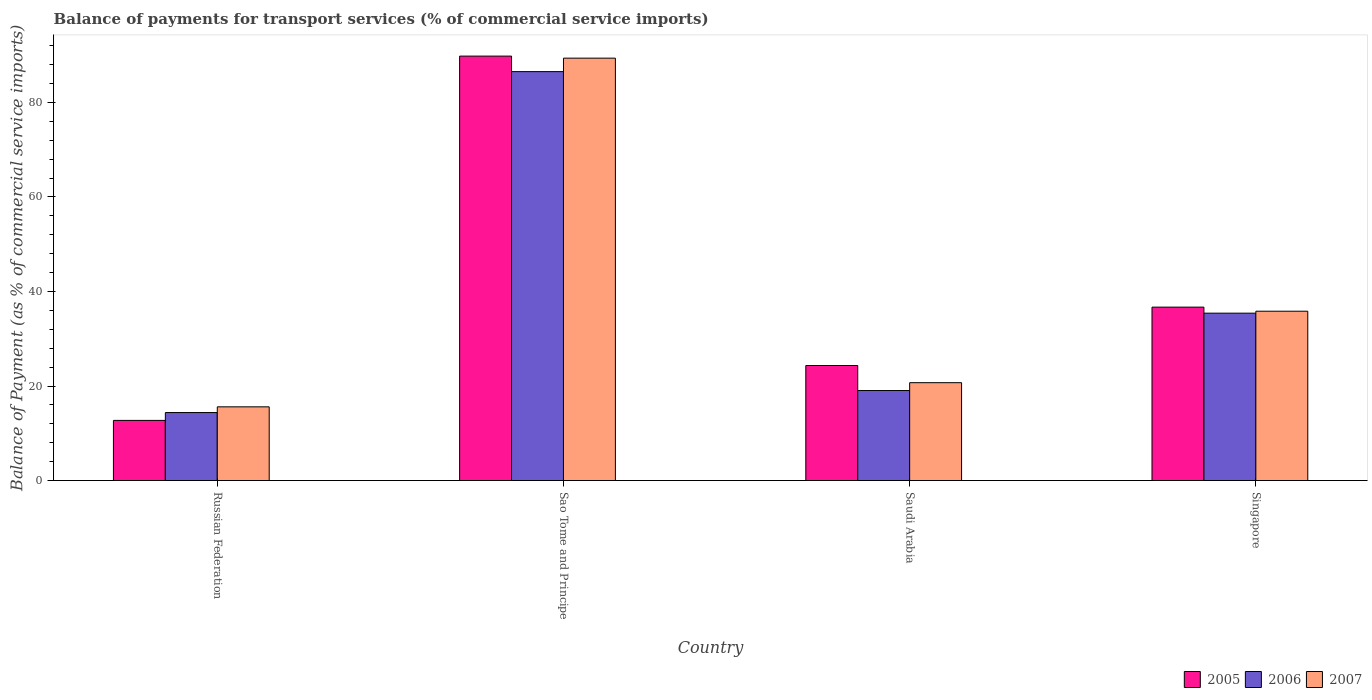How many different coloured bars are there?
Your answer should be compact. 3. How many bars are there on the 3rd tick from the left?
Provide a succinct answer. 3. How many bars are there on the 1st tick from the right?
Provide a short and direct response. 3. What is the label of the 3rd group of bars from the left?
Give a very brief answer. Saudi Arabia. In how many cases, is the number of bars for a given country not equal to the number of legend labels?
Give a very brief answer. 0. What is the balance of payments for transport services in 2007 in Singapore?
Make the answer very short. 35.83. Across all countries, what is the maximum balance of payments for transport services in 2006?
Your response must be concise. 86.52. Across all countries, what is the minimum balance of payments for transport services in 2006?
Keep it short and to the point. 14.39. In which country was the balance of payments for transport services in 2007 maximum?
Offer a very short reply. Sao Tome and Principe. In which country was the balance of payments for transport services in 2007 minimum?
Offer a very short reply. Russian Federation. What is the total balance of payments for transport services in 2005 in the graph?
Provide a succinct answer. 163.58. What is the difference between the balance of payments for transport services in 2006 in Russian Federation and that in Singapore?
Provide a short and direct response. -21.03. What is the difference between the balance of payments for transport services in 2005 in Sao Tome and Principe and the balance of payments for transport services in 2006 in Singapore?
Your answer should be very brief. 54.39. What is the average balance of payments for transport services in 2005 per country?
Your answer should be compact. 40.89. What is the difference between the balance of payments for transport services of/in 2007 and balance of payments for transport services of/in 2006 in Sao Tome and Principe?
Make the answer very short. 2.85. In how many countries, is the balance of payments for transport services in 2005 greater than 52 %?
Offer a very short reply. 1. What is the ratio of the balance of payments for transport services in 2006 in Russian Federation to that in Singapore?
Keep it short and to the point. 0.41. What is the difference between the highest and the second highest balance of payments for transport services in 2005?
Offer a very short reply. -65.46. What is the difference between the highest and the lowest balance of payments for transport services in 2006?
Offer a very short reply. 72.13. In how many countries, is the balance of payments for transport services in 2005 greater than the average balance of payments for transport services in 2005 taken over all countries?
Offer a terse response. 1. Is the sum of the balance of payments for transport services in 2005 in Sao Tome and Principe and Saudi Arabia greater than the maximum balance of payments for transport services in 2006 across all countries?
Provide a short and direct response. Yes. What does the 3rd bar from the left in Sao Tome and Principe represents?
Your response must be concise. 2007. What does the 2nd bar from the right in Singapore represents?
Your answer should be compact. 2006. Is it the case that in every country, the sum of the balance of payments for transport services in 2006 and balance of payments for transport services in 2005 is greater than the balance of payments for transport services in 2007?
Give a very brief answer. Yes. How many bars are there?
Provide a short and direct response. 12. How many countries are there in the graph?
Your answer should be very brief. 4. What is the difference between two consecutive major ticks on the Y-axis?
Ensure brevity in your answer.  20. Are the values on the major ticks of Y-axis written in scientific E-notation?
Offer a terse response. No. Does the graph contain any zero values?
Provide a short and direct response. No. Where does the legend appear in the graph?
Your response must be concise. Bottom right. How many legend labels are there?
Ensure brevity in your answer.  3. How are the legend labels stacked?
Your answer should be very brief. Horizontal. What is the title of the graph?
Offer a very short reply. Balance of payments for transport services (% of commercial service imports). What is the label or title of the Y-axis?
Keep it short and to the point. Balance of Payment (as % of commercial service imports). What is the Balance of Payment (as % of commercial service imports) in 2005 in Russian Federation?
Your answer should be compact. 12.73. What is the Balance of Payment (as % of commercial service imports) of 2006 in Russian Federation?
Your answer should be very brief. 14.39. What is the Balance of Payment (as % of commercial service imports) of 2007 in Russian Federation?
Keep it short and to the point. 15.6. What is the Balance of Payment (as % of commercial service imports) of 2005 in Sao Tome and Principe?
Provide a succinct answer. 89.8. What is the Balance of Payment (as % of commercial service imports) of 2006 in Sao Tome and Principe?
Offer a terse response. 86.52. What is the Balance of Payment (as % of commercial service imports) of 2007 in Sao Tome and Principe?
Your answer should be compact. 89.37. What is the Balance of Payment (as % of commercial service imports) of 2005 in Saudi Arabia?
Offer a terse response. 24.34. What is the Balance of Payment (as % of commercial service imports) in 2006 in Saudi Arabia?
Provide a succinct answer. 19.05. What is the Balance of Payment (as % of commercial service imports) of 2007 in Saudi Arabia?
Your answer should be compact. 20.71. What is the Balance of Payment (as % of commercial service imports) of 2005 in Singapore?
Make the answer very short. 36.69. What is the Balance of Payment (as % of commercial service imports) in 2006 in Singapore?
Give a very brief answer. 35.42. What is the Balance of Payment (as % of commercial service imports) of 2007 in Singapore?
Your answer should be compact. 35.83. Across all countries, what is the maximum Balance of Payment (as % of commercial service imports) of 2005?
Give a very brief answer. 89.8. Across all countries, what is the maximum Balance of Payment (as % of commercial service imports) of 2006?
Ensure brevity in your answer.  86.52. Across all countries, what is the maximum Balance of Payment (as % of commercial service imports) of 2007?
Provide a short and direct response. 89.37. Across all countries, what is the minimum Balance of Payment (as % of commercial service imports) in 2005?
Ensure brevity in your answer.  12.73. Across all countries, what is the minimum Balance of Payment (as % of commercial service imports) of 2006?
Your answer should be very brief. 14.39. Across all countries, what is the minimum Balance of Payment (as % of commercial service imports) of 2007?
Ensure brevity in your answer.  15.6. What is the total Balance of Payment (as % of commercial service imports) in 2005 in the graph?
Keep it short and to the point. 163.58. What is the total Balance of Payment (as % of commercial service imports) of 2006 in the graph?
Your response must be concise. 155.38. What is the total Balance of Payment (as % of commercial service imports) in 2007 in the graph?
Offer a terse response. 161.51. What is the difference between the Balance of Payment (as % of commercial service imports) in 2005 in Russian Federation and that in Sao Tome and Principe?
Your response must be concise. -77.07. What is the difference between the Balance of Payment (as % of commercial service imports) in 2006 in Russian Federation and that in Sao Tome and Principe?
Provide a succinct answer. -72.13. What is the difference between the Balance of Payment (as % of commercial service imports) in 2007 in Russian Federation and that in Sao Tome and Principe?
Offer a very short reply. -73.77. What is the difference between the Balance of Payment (as % of commercial service imports) in 2005 in Russian Federation and that in Saudi Arabia?
Give a very brief answer. -11.61. What is the difference between the Balance of Payment (as % of commercial service imports) of 2006 in Russian Federation and that in Saudi Arabia?
Offer a very short reply. -4.66. What is the difference between the Balance of Payment (as % of commercial service imports) in 2007 in Russian Federation and that in Saudi Arabia?
Give a very brief answer. -5.11. What is the difference between the Balance of Payment (as % of commercial service imports) in 2005 in Russian Federation and that in Singapore?
Provide a succinct answer. -23.96. What is the difference between the Balance of Payment (as % of commercial service imports) in 2006 in Russian Federation and that in Singapore?
Provide a short and direct response. -21.03. What is the difference between the Balance of Payment (as % of commercial service imports) in 2007 in Russian Federation and that in Singapore?
Your answer should be compact. -20.23. What is the difference between the Balance of Payment (as % of commercial service imports) of 2005 in Sao Tome and Principe and that in Saudi Arabia?
Ensure brevity in your answer.  65.46. What is the difference between the Balance of Payment (as % of commercial service imports) in 2006 in Sao Tome and Principe and that in Saudi Arabia?
Give a very brief answer. 67.47. What is the difference between the Balance of Payment (as % of commercial service imports) of 2007 in Sao Tome and Principe and that in Saudi Arabia?
Offer a very short reply. 68.66. What is the difference between the Balance of Payment (as % of commercial service imports) of 2005 in Sao Tome and Principe and that in Singapore?
Make the answer very short. 53.11. What is the difference between the Balance of Payment (as % of commercial service imports) of 2006 in Sao Tome and Principe and that in Singapore?
Give a very brief answer. 51.1. What is the difference between the Balance of Payment (as % of commercial service imports) of 2007 in Sao Tome and Principe and that in Singapore?
Your response must be concise. 53.54. What is the difference between the Balance of Payment (as % of commercial service imports) of 2005 in Saudi Arabia and that in Singapore?
Your response must be concise. -12.35. What is the difference between the Balance of Payment (as % of commercial service imports) in 2006 in Saudi Arabia and that in Singapore?
Provide a succinct answer. -16.37. What is the difference between the Balance of Payment (as % of commercial service imports) of 2007 in Saudi Arabia and that in Singapore?
Your answer should be very brief. -15.12. What is the difference between the Balance of Payment (as % of commercial service imports) of 2005 in Russian Federation and the Balance of Payment (as % of commercial service imports) of 2006 in Sao Tome and Principe?
Offer a terse response. -73.79. What is the difference between the Balance of Payment (as % of commercial service imports) in 2005 in Russian Federation and the Balance of Payment (as % of commercial service imports) in 2007 in Sao Tome and Principe?
Your answer should be very brief. -76.64. What is the difference between the Balance of Payment (as % of commercial service imports) in 2006 in Russian Federation and the Balance of Payment (as % of commercial service imports) in 2007 in Sao Tome and Principe?
Provide a succinct answer. -74.98. What is the difference between the Balance of Payment (as % of commercial service imports) in 2005 in Russian Federation and the Balance of Payment (as % of commercial service imports) in 2006 in Saudi Arabia?
Your response must be concise. -6.32. What is the difference between the Balance of Payment (as % of commercial service imports) in 2005 in Russian Federation and the Balance of Payment (as % of commercial service imports) in 2007 in Saudi Arabia?
Your answer should be compact. -7.98. What is the difference between the Balance of Payment (as % of commercial service imports) of 2006 in Russian Federation and the Balance of Payment (as % of commercial service imports) of 2007 in Saudi Arabia?
Offer a very short reply. -6.32. What is the difference between the Balance of Payment (as % of commercial service imports) of 2005 in Russian Federation and the Balance of Payment (as % of commercial service imports) of 2006 in Singapore?
Your answer should be compact. -22.69. What is the difference between the Balance of Payment (as % of commercial service imports) of 2005 in Russian Federation and the Balance of Payment (as % of commercial service imports) of 2007 in Singapore?
Make the answer very short. -23.1. What is the difference between the Balance of Payment (as % of commercial service imports) of 2006 in Russian Federation and the Balance of Payment (as % of commercial service imports) of 2007 in Singapore?
Your answer should be compact. -21.44. What is the difference between the Balance of Payment (as % of commercial service imports) in 2005 in Sao Tome and Principe and the Balance of Payment (as % of commercial service imports) in 2006 in Saudi Arabia?
Offer a terse response. 70.75. What is the difference between the Balance of Payment (as % of commercial service imports) of 2005 in Sao Tome and Principe and the Balance of Payment (as % of commercial service imports) of 2007 in Saudi Arabia?
Provide a short and direct response. 69.09. What is the difference between the Balance of Payment (as % of commercial service imports) in 2006 in Sao Tome and Principe and the Balance of Payment (as % of commercial service imports) in 2007 in Saudi Arabia?
Provide a succinct answer. 65.81. What is the difference between the Balance of Payment (as % of commercial service imports) in 2005 in Sao Tome and Principe and the Balance of Payment (as % of commercial service imports) in 2006 in Singapore?
Keep it short and to the point. 54.39. What is the difference between the Balance of Payment (as % of commercial service imports) in 2005 in Sao Tome and Principe and the Balance of Payment (as % of commercial service imports) in 2007 in Singapore?
Keep it short and to the point. 53.97. What is the difference between the Balance of Payment (as % of commercial service imports) in 2006 in Sao Tome and Principe and the Balance of Payment (as % of commercial service imports) in 2007 in Singapore?
Your response must be concise. 50.69. What is the difference between the Balance of Payment (as % of commercial service imports) in 2005 in Saudi Arabia and the Balance of Payment (as % of commercial service imports) in 2006 in Singapore?
Your answer should be compact. -11.07. What is the difference between the Balance of Payment (as % of commercial service imports) of 2005 in Saudi Arabia and the Balance of Payment (as % of commercial service imports) of 2007 in Singapore?
Your answer should be very brief. -11.49. What is the difference between the Balance of Payment (as % of commercial service imports) in 2006 in Saudi Arabia and the Balance of Payment (as % of commercial service imports) in 2007 in Singapore?
Provide a short and direct response. -16.78. What is the average Balance of Payment (as % of commercial service imports) of 2005 per country?
Provide a short and direct response. 40.89. What is the average Balance of Payment (as % of commercial service imports) of 2006 per country?
Offer a terse response. 38.84. What is the average Balance of Payment (as % of commercial service imports) in 2007 per country?
Your answer should be very brief. 40.38. What is the difference between the Balance of Payment (as % of commercial service imports) of 2005 and Balance of Payment (as % of commercial service imports) of 2006 in Russian Federation?
Your answer should be very brief. -1.66. What is the difference between the Balance of Payment (as % of commercial service imports) of 2005 and Balance of Payment (as % of commercial service imports) of 2007 in Russian Federation?
Provide a succinct answer. -2.87. What is the difference between the Balance of Payment (as % of commercial service imports) of 2006 and Balance of Payment (as % of commercial service imports) of 2007 in Russian Federation?
Ensure brevity in your answer.  -1.21. What is the difference between the Balance of Payment (as % of commercial service imports) of 2005 and Balance of Payment (as % of commercial service imports) of 2006 in Sao Tome and Principe?
Provide a succinct answer. 3.28. What is the difference between the Balance of Payment (as % of commercial service imports) in 2005 and Balance of Payment (as % of commercial service imports) in 2007 in Sao Tome and Principe?
Your answer should be compact. 0.43. What is the difference between the Balance of Payment (as % of commercial service imports) of 2006 and Balance of Payment (as % of commercial service imports) of 2007 in Sao Tome and Principe?
Provide a succinct answer. -2.85. What is the difference between the Balance of Payment (as % of commercial service imports) in 2005 and Balance of Payment (as % of commercial service imports) in 2006 in Saudi Arabia?
Provide a short and direct response. 5.29. What is the difference between the Balance of Payment (as % of commercial service imports) of 2005 and Balance of Payment (as % of commercial service imports) of 2007 in Saudi Arabia?
Provide a short and direct response. 3.63. What is the difference between the Balance of Payment (as % of commercial service imports) of 2006 and Balance of Payment (as % of commercial service imports) of 2007 in Saudi Arabia?
Make the answer very short. -1.66. What is the difference between the Balance of Payment (as % of commercial service imports) in 2005 and Balance of Payment (as % of commercial service imports) in 2006 in Singapore?
Offer a terse response. 1.28. What is the difference between the Balance of Payment (as % of commercial service imports) of 2005 and Balance of Payment (as % of commercial service imports) of 2007 in Singapore?
Your answer should be compact. 0.86. What is the difference between the Balance of Payment (as % of commercial service imports) of 2006 and Balance of Payment (as % of commercial service imports) of 2007 in Singapore?
Provide a succinct answer. -0.41. What is the ratio of the Balance of Payment (as % of commercial service imports) of 2005 in Russian Federation to that in Sao Tome and Principe?
Provide a succinct answer. 0.14. What is the ratio of the Balance of Payment (as % of commercial service imports) of 2006 in Russian Federation to that in Sao Tome and Principe?
Provide a short and direct response. 0.17. What is the ratio of the Balance of Payment (as % of commercial service imports) of 2007 in Russian Federation to that in Sao Tome and Principe?
Your answer should be very brief. 0.17. What is the ratio of the Balance of Payment (as % of commercial service imports) of 2005 in Russian Federation to that in Saudi Arabia?
Your response must be concise. 0.52. What is the ratio of the Balance of Payment (as % of commercial service imports) in 2006 in Russian Federation to that in Saudi Arabia?
Provide a succinct answer. 0.76. What is the ratio of the Balance of Payment (as % of commercial service imports) in 2007 in Russian Federation to that in Saudi Arabia?
Your answer should be very brief. 0.75. What is the ratio of the Balance of Payment (as % of commercial service imports) in 2005 in Russian Federation to that in Singapore?
Ensure brevity in your answer.  0.35. What is the ratio of the Balance of Payment (as % of commercial service imports) of 2006 in Russian Federation to that in Singapore?
Provide a short and direct response. 0.41. What is the ratio of the Balance of Payment (as % of commercial service imports) in 2007 in Russian Federation to that in Singapore?
Offer a terse response. 0.44. What is the ratio of the Balance of Payment (as % of commercial service imports) in 2005 in Sao Tome and Principe to that in Saudi Arabia?
Offer a terse response. 3.69. What is the ratio of the Balance of Payment (as % of commercial service imports) in 2006 in Sao Tome and Principe to that in Saudi Arabia?
Offer a terse response. 4.54. What is the ratio of the Balance of Payment (as % of commercial service imports) of 2007 in Sao Tome and Principe to that in Saudi Arabia?
Provide a succinct answer. 4.32. What is the ratio of the Balance of Payment (as % of commercial service imports) in 2005 in Sao Tome and Principe to that in Singapore?
Your answer should be compact. 2.45. What is the ratio of the Balance of Payment (as % of commercial service imports) in 2006 in Sao Tome and Principe to that in Singapore?
Give a very brief answer. 2.44. What is the ratio of the Balance of Payment (as % of commercial service imports) of 2007 in Sao Tome and Principe to that in Singapore?
Your response must be concise. 2.49. What is the ratio of the Balance of Payment (as % of commercial service imports) in 2005 in Saudi Arabia to that in Singapore?
Keep it short and to the point. 0.66. What is the ratio of the Balance of Payment (as % of commercial service imports) of 2006 in Saudi Arabia to that in Singapore?
Provide a succinct answer. 0.54. What is the ratio of the Balance of Payment (as % of commercial service imports) in 2007 in Saudi Arabia to that in Singapore?
Provide a short and direct response. 0.58. What is the difference between the highest and the second highest Balance of Payment (as % of commercial service imports) in 2005?
Keep it short and to the point. 53.11. What is the difference between the highest and the second highest Balance of Payment (as % of commercial service imports) in 2006?
Your answer should be compact. 51.1. What is the difference between the highest and the second highest Balance of Payment (as % of commercial service imports) of 2007?
Offer a very short reply. 53.54. What is the difference between the highest and the lowest Balance of Payment (as % of commercial service imports) of 2005?
Give a very brief answer. 77.07. What is the difference between the highest and the lowest Balance of Payment (as % of commercial service imports) of 2006?
Your answer should be very brief. 72.13. What is the difference between the highest and the lowest Balance of Payment (as % of commercial service imports) in 2007?
Make the answer very short. 73.77. 